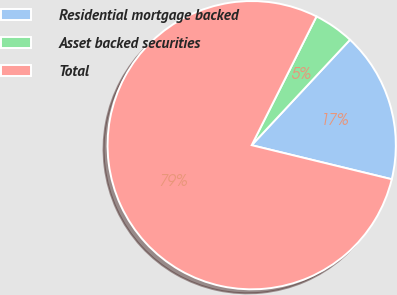Convert chart to OTSL. <chart><loc_0><loc_0><loc_500><loc_500><pie_chart><fcel>Residential mortgage backed<fcel>Asset backed securities<fcel>Total<nl><fcel>16.85%<fcel>4.52%<fcel>78.62%<nl></chart> 